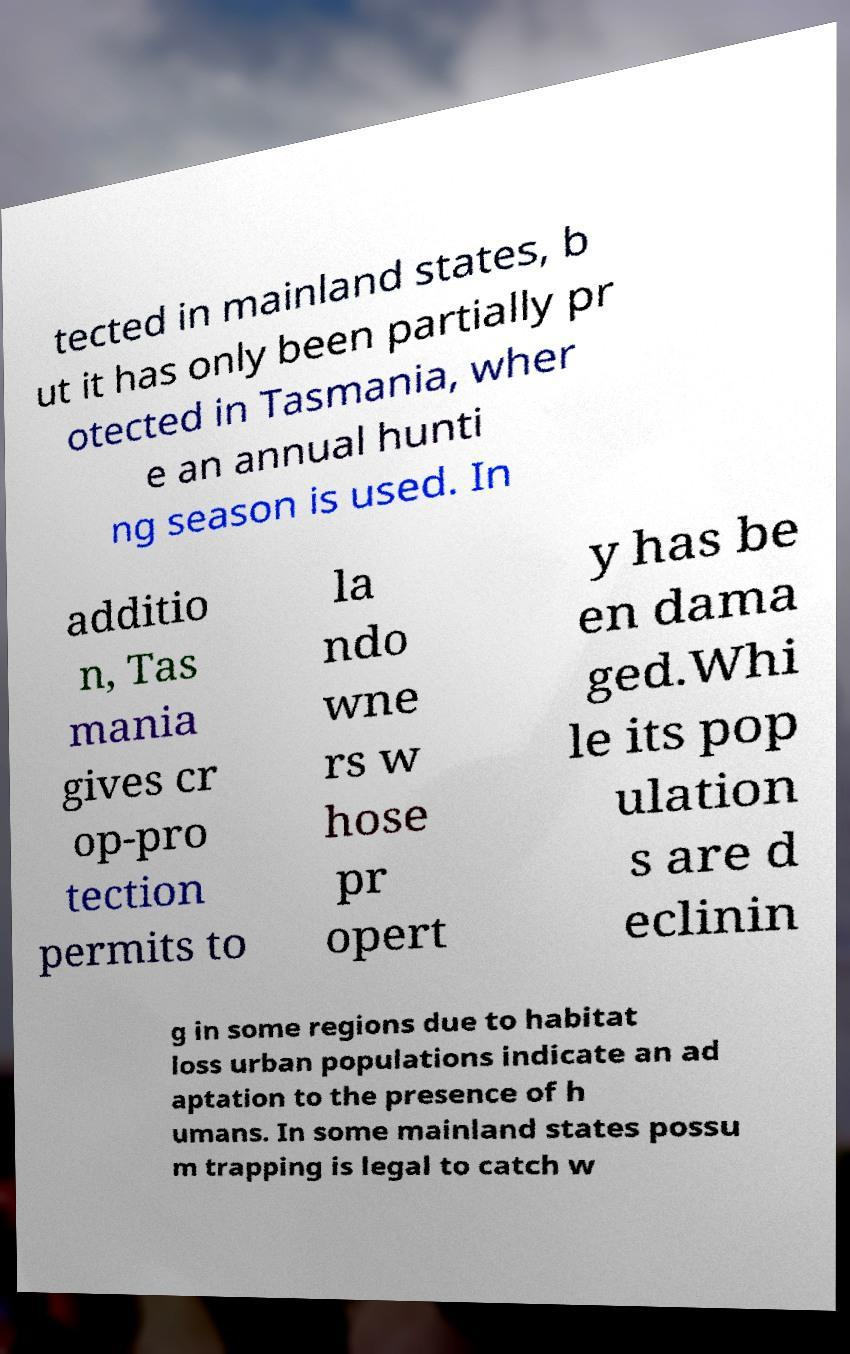Could you extract and type out the text from this image? tected in mainland states, b ut it has only been partially pr otected in Tasmania, wher e an annual hunti ng season is used. In additio n, Tas mania gives cr op-pro tection permits to la ndo wne rs w hose pr opert y has be en dama ged.Whi le its pop ulation s are d eclinin g in some regions due to habitat loss urban populations indicate an ad aptation to the presence of h umans. In some mainland states possu m trapping is legal to catch w 